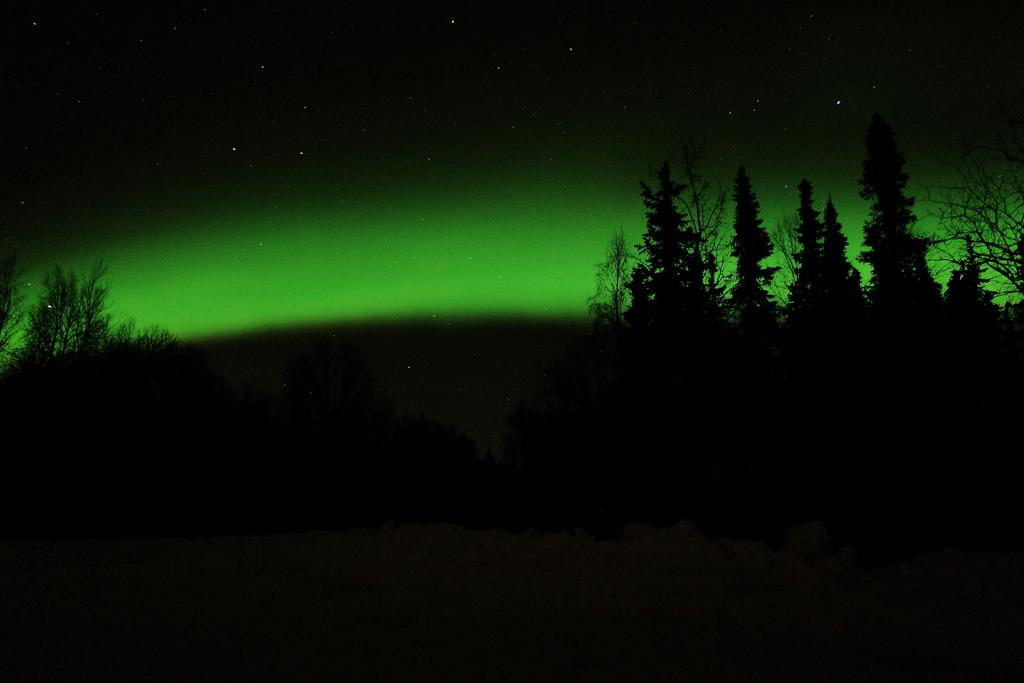What type of terrain is visible in the image? There is land visible in the image. What type of vegetation can be seen on the land? There are trees in the image. What is visible at the top of the image? The sky is visible at the top of the image. What celestial objects can be seen in the sky? Stars are present in the sky. What color is the pencil used to draw the suggestion in the image? There is no pencil or suggestion present in the image. How does the scarf contribute to the overall composition of the image? There is no scarf present in the image. 